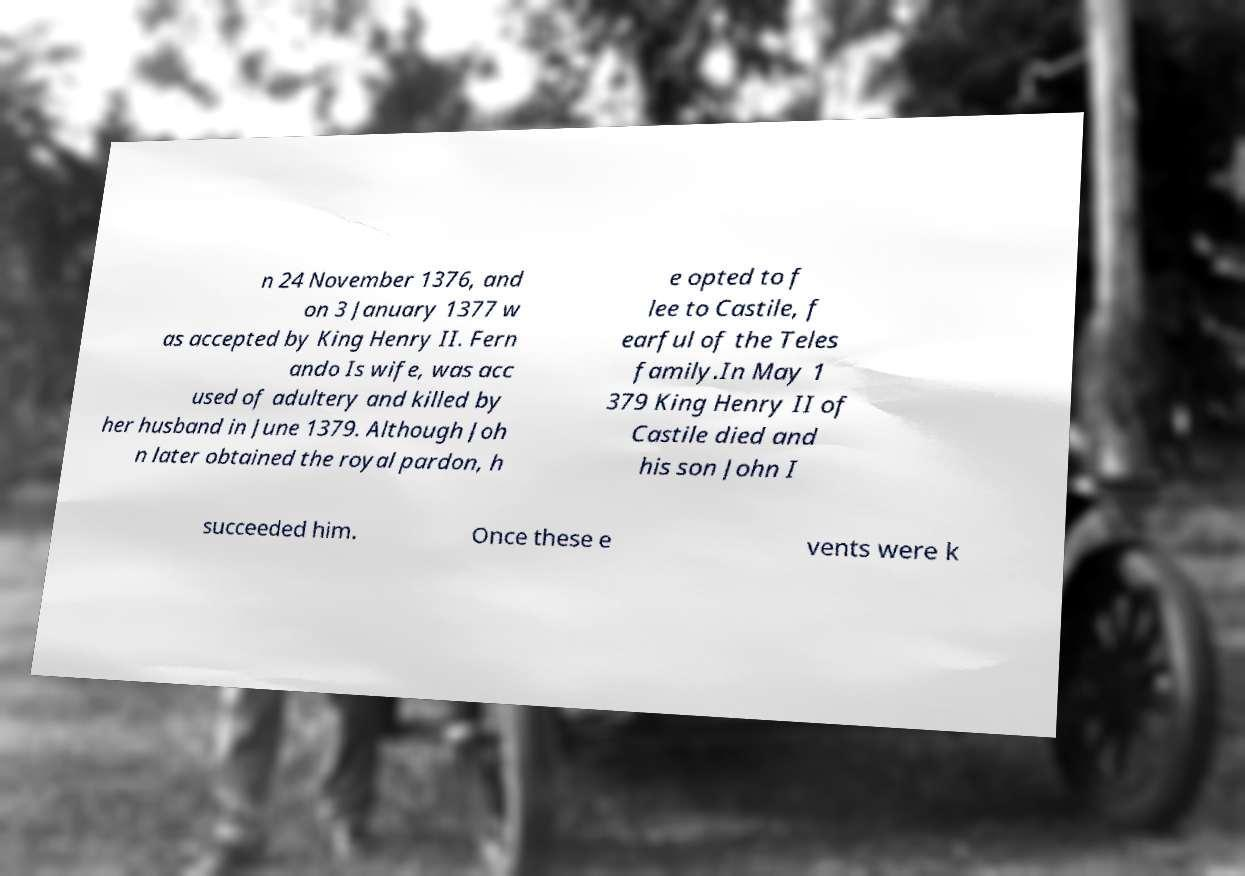Can you read and provide the text displayed in the image?This photo seems to have some interesting text. Can you extract and type it out for me? n 24 November 1376, and on 3 January 1377 w as accepted by King Henry II. Fern ando Is wife, was acc used of adultery and killed by her husband in June 1379. Although Joh n later obtained the royal pardon, h e opted to f lee to Castile, f earful of the Teles family.In May 1 379 King Henry II of Castile died and his son John I succeeded him. Once these e vents were k 